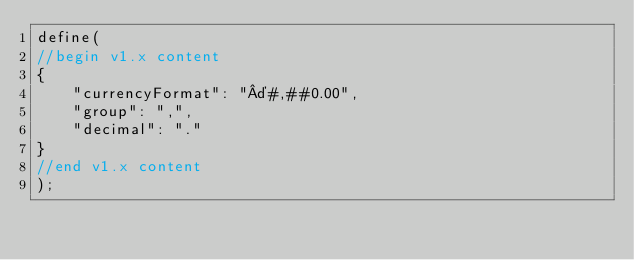Convert code to text. <code><loc_0><loc_0><loc_500><loc_500><_JavaScript_>define(
//begin v1.x content
{
	"currencyFormat": "¤#,##0.00",
	"group": ",",
	"decimal": "."
}
//end v1.x content
);</code> 